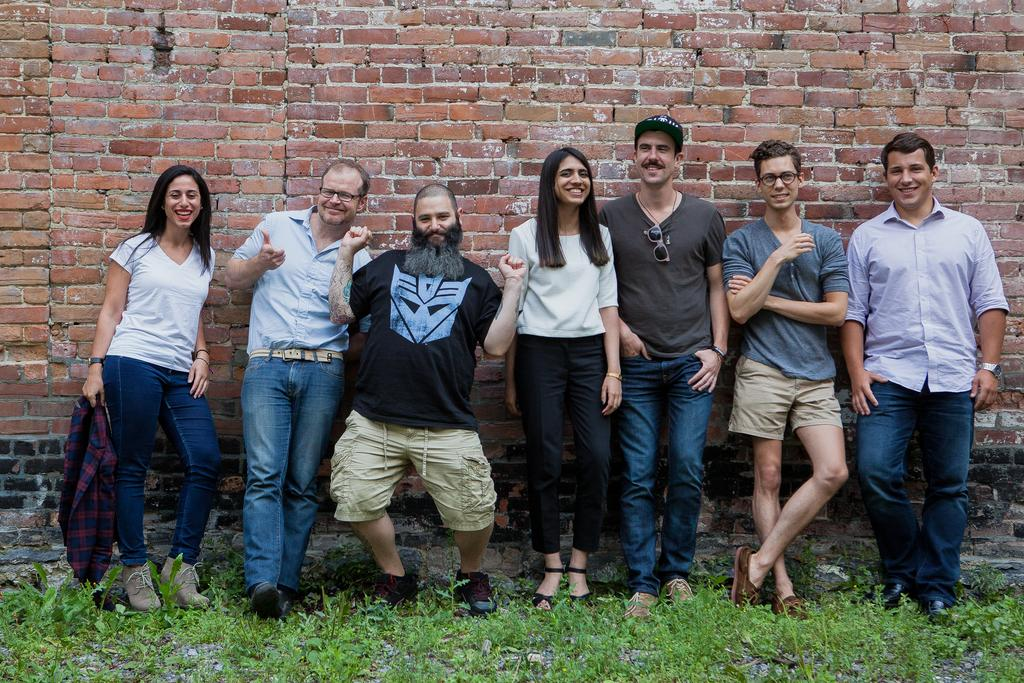How many people are in the image? There is a group of people in the image, but the exact number is not specified. What are the people doing in the image? The people are standing on the ground and smiling. What type of surface are the people standing on? The people are standing on the ground. What can be seen growing in the image? There is grass visible in the image. What is visible in the background of the image? There is a wall in the background of the image. What type of design can be seen on the kite in the image? There is no kite present in the image, so it is not possible to answer that question. 